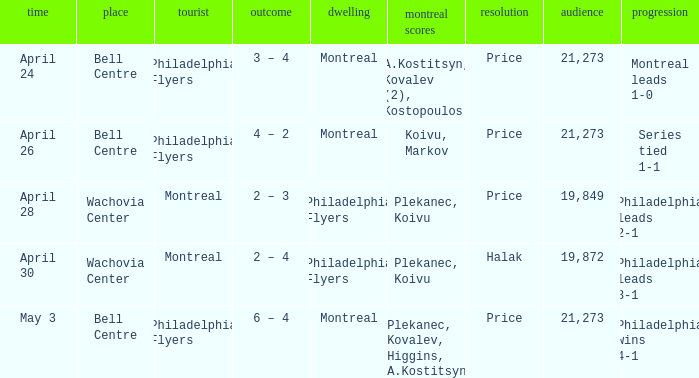What was the average attendance when the decision was price and montreal were the visitors? 19849.0. 